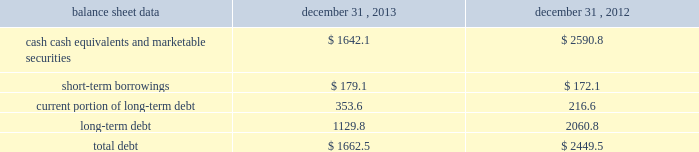Management 2019s discussion and analysis of financial condition and results of operations 2013 ( continued ) ( amounts in millions , except per share amounts ) net cash used in investing activities during 2012 primarily related to payments for capital expenditures and acquisitions , partially offset by the net proceeds of $ 94.8 received from the sale of our remaining holdings in facebook .
Capital expenditures of $ 169.2 primarily related to computer hardware and software , and leasehold improvements .
Capital expenditures increased in 2012 compared to the prior year , primarily due to an increase in leasehold improvements made during the year .
Payments for acquisitions of $ 145.5 primarily related to payments for new acquisitions .
Financing activities net cash used in financing activities during 2013 primarily related to the purchase of long-term debt , the repurchase of our common stock , and payment of dividends .
We redeemed all $ 600.0 in aggregate principal amount of our 10.00% ( 10.00 % ) notes .
In addition , we repurchased 31.8 shares of our common stock for an aggregate cost of $ 481.8 , including fees , and made dividend payments of $ 126.0 on our common stock .
Net cash provided by financing activities during 2012 primarily reflected net proceeds from our debt transactions .
We issued $ 300.0 in aggregate principal amount of 2.25% ( 2.25 % ) senior notes due 2017 ( the 201c2.25% ( 201c2.25 % ) notes 201d ) , $ 500.0 in aggregate principal amount of 3.75% ( 3.75 % ) senior notes due 2023 ( the 201c3.75% ( 201c3.75 % ) notes 201d ) and $ 250.0 in aggregate principal amount of 4.00% ( 4.00 % ) senior notes due 2022 ( the 201c4.00% ( 201c4.00 % ) notes 201d ) .
The proceeds from the issuance of the 4.00% ( 4.00 % ) notes were applied towards the repurchase and redemption of $ 399.6 in aggregate principal amount of our 4.25% ( 4.25 % ) notes .
Offsetting the net proceeds from our debt transactions was the repurchase of 32.7 shares of our common stock for an aggregate cost of $ 350.5 , including fees , and dividend payments of $ 103.4 on our common stock .
Foreign exchange rate changes the effect of foreign exchange rate changes on cash and cash equivalents included in the consolidated statements of cash flows resulted in a decrease of $ 94.1 in 2013 .
The decrease was primarily a result of the u.s .
Dollar being stronger than several foreign currencies , including the australian dollar , brazilian real , japanese yen , canadian dollar and south african rand as of december 31 , 2013 compared to december 31 , 2012 .
The effect of foreign exchange rate changes on cash and cash equivalents included in the consolidated statements of cash flows resulted in a decrease of $ 6.2 in 2012 .
The decrease was a result of the u.s .
Dollar being stronger than several foreign currencies , including the brazilian real and south african rand , offset by the u.s .
Dollar being weaker than other foreign currencies , including the australian dollar , british pound and the euro , as of as of december 31 , 2012 compared to december 31 , 2011. .
Liquidity outlook we expect our cash flow from operations , cash and cash equivalents to be sufficient to meet our anticipated operating requirements at a minimum for the next twelve months .
We also have a committed corporate credit facility as well as uncommitted facilities available to support our operating needs .
We continue to maintain a disciplined approach to managing liquidity , with flexibility over significant uses of cash , including our capital expenditures , cash used for new acquisitions , our common stock repurchase program and our common stock dividends. .
What is the growth rate in the balance of cash , cash equivalents and marketable securities from 2012 to 2013? 
Computations: ((1642.1 - 2590.8) / 2590.8)
Answer: -0.36618. 